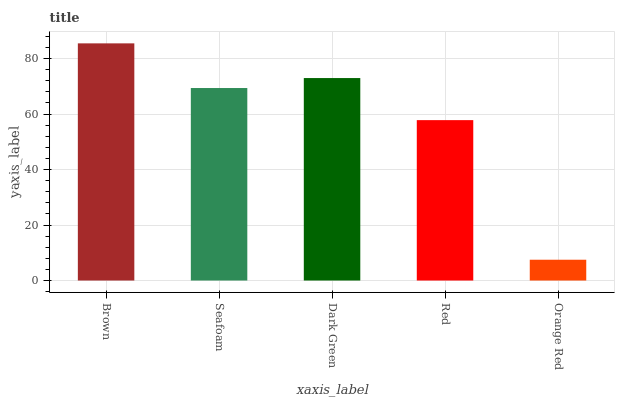Is Orange Red the minimum?
Answer yes or no. Yes. Is Brown the maximum?
Answer yes or no. Yes. Is Seafoam the minimum?
Answer yes or no. No. Is Seafoam the maximum?
Answer yes or no. No. Is Brown greater than Seafoam?
Answer yes or no. Yes. Is Seafoam less than Brown?
Answer yes or no. Yes. Is Seafoam greater than Brown?
Answer yes or no. No. Is Brown less than Seafoam?
Answer yes or no. No. Is Seafoam the high median?
Answer yes or no. Yes. Is Seafoam the low median?
Answer yes or no. Yes. Is Dark Green the high median?
Answer yes or no. No. Is Red the low median?
Answer yes or no. No. 